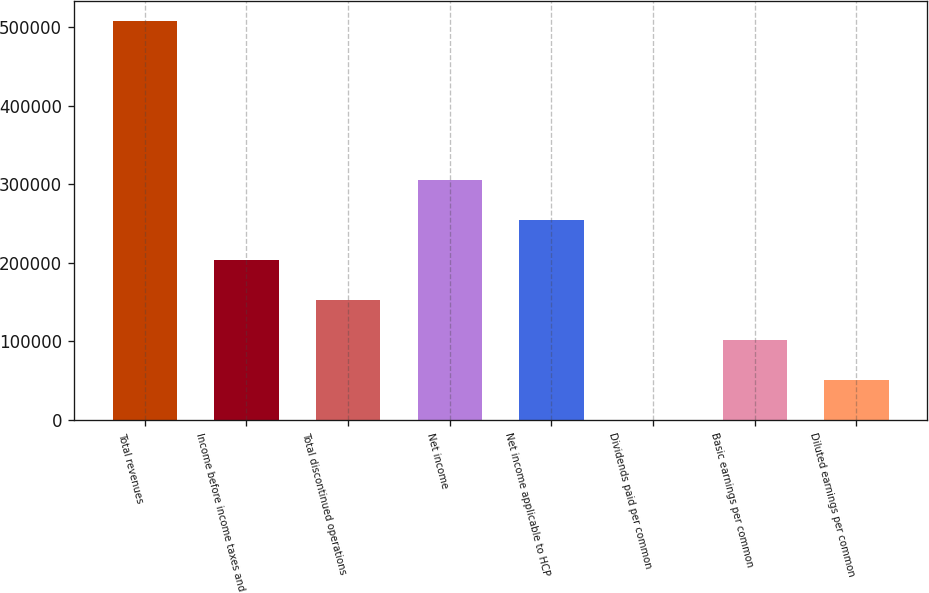Convert chart. <chart><loc_0><loc_0><loc_500><loc_500><bar_chart><fcel>Total revenues<fcel>Income before income taxes and<fcel>Total discontinued operations<fcel>Net income<fcel>Net income applicable to HCP<fcel>Dividends paid per common<fcel>Basic earnings per common<fcel>Diluted earnings per common<nl><fcel>508487<fcel>203395<fcel>152546<fcel>305092<fcel>254244<fcel>0.5<fcel>101698<fcel>50849.2<nl></chart> 